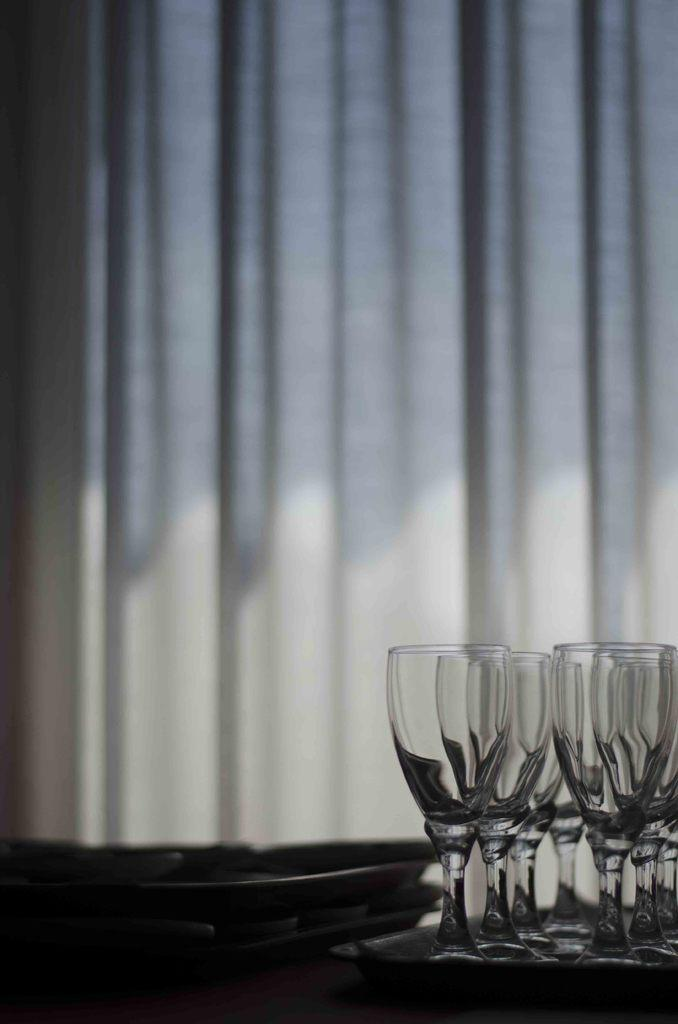What type of glasses can be seen on the right side of the image? There are wine glasses on the right side of the image. What else is visible in the image besides the wine glasses? There is a curtain visible in the image. Where is the map located in the image? There is no map present in the image. What type of cloth is draped over the wine glasses? There is no cloth draped over the wine glasses in the image. 